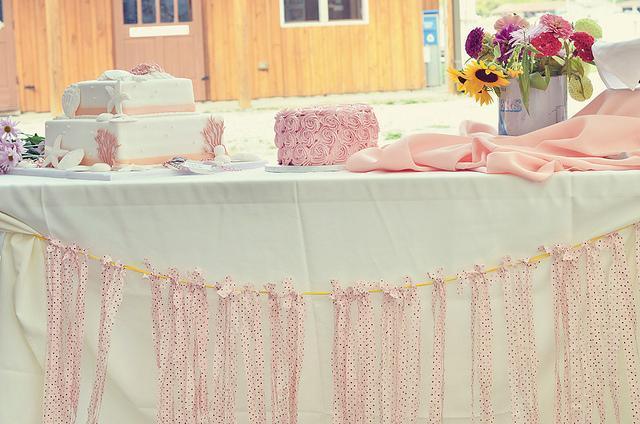How many cakes are there?
Give a very brief answer. 2. How many cakes are visible?
Give a very brief answer. 2. How many people appear in the picture?
Give a very brief answer. 0. 